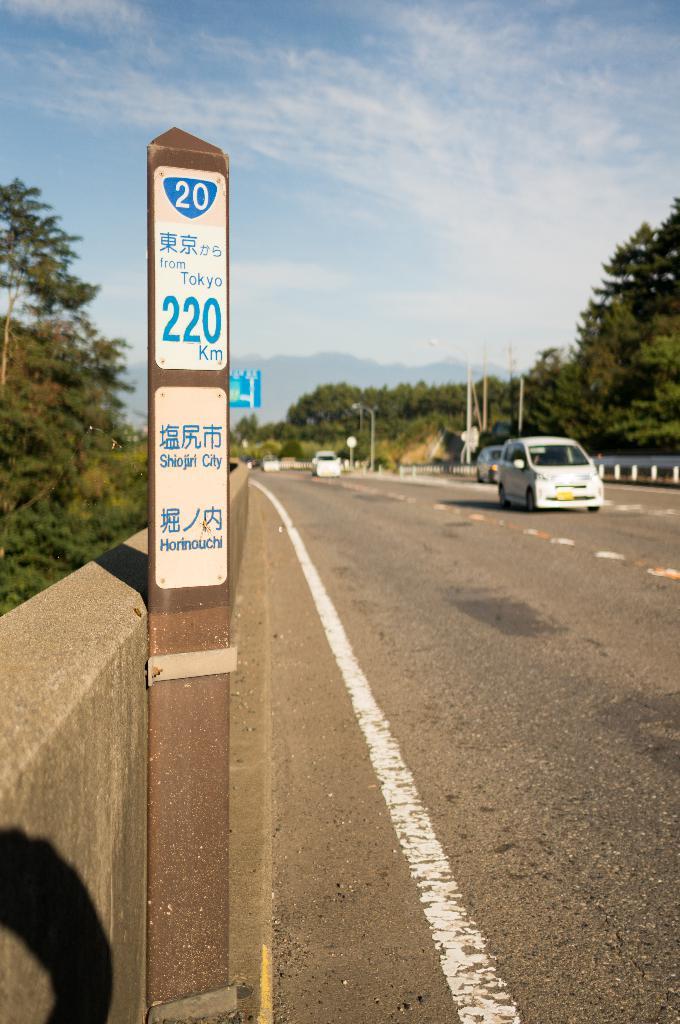What city is on the bottom sign?
Keep it short and to the point. Shiojiri. 